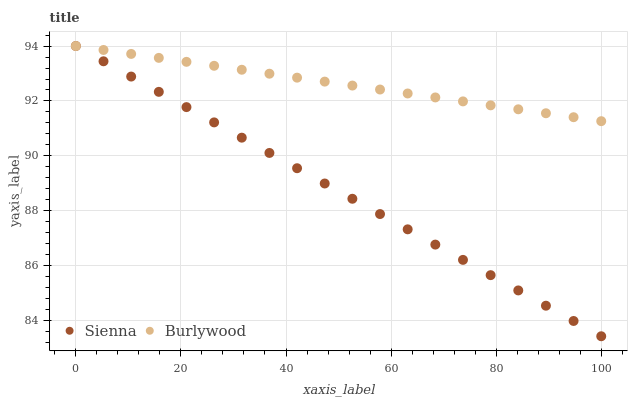Does Sienna have the minimum area under the curve?
Answer yes or no. Yes. Does Burlywood have the maximum area under the curve?
Answer yes or no. Yes. Does Burlywood have the minimum area under the curve?
Answer yes or no. No. Is Burlywood the smoothest?
Answer yes or no. Yes. Is Sienna the roughest?
Answer yes or no. Yes. Is Burlywood the roughest?
Answer yes or no. No. Does Sienna have the lowest value?
Answer yes or no. Yes. Does Burlywood have the lowest value?
Answer yes or no. No. Does Burlywood have the highest value?
Answer yes or no. Yes. Does Sienna intersect Burlywood?
Answer yes or no. Yes. Is Sienna less than Burlywood?
Answer yes or no. No. Is Sienna greater than Burlywood?
Answer yes or no. No. 